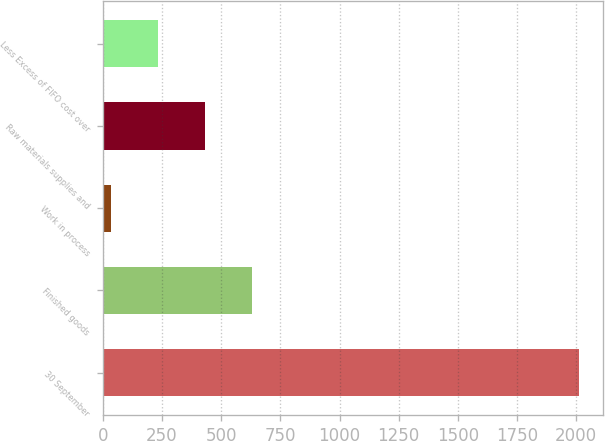Convert chart to OTSL. <chart><loc_0><loc_0><loc_500><loc_500><bar_chart><fcel>30 September<fcel>Finished goods<fcel>Work in process<fcel>Raw materials supplies and<fcel>Less Excess of FIFO cost over<nl><fcel>2012<fcel>629.29<fcel>36.7<fcel>431.76<fcel>234.23<nl></chart> 